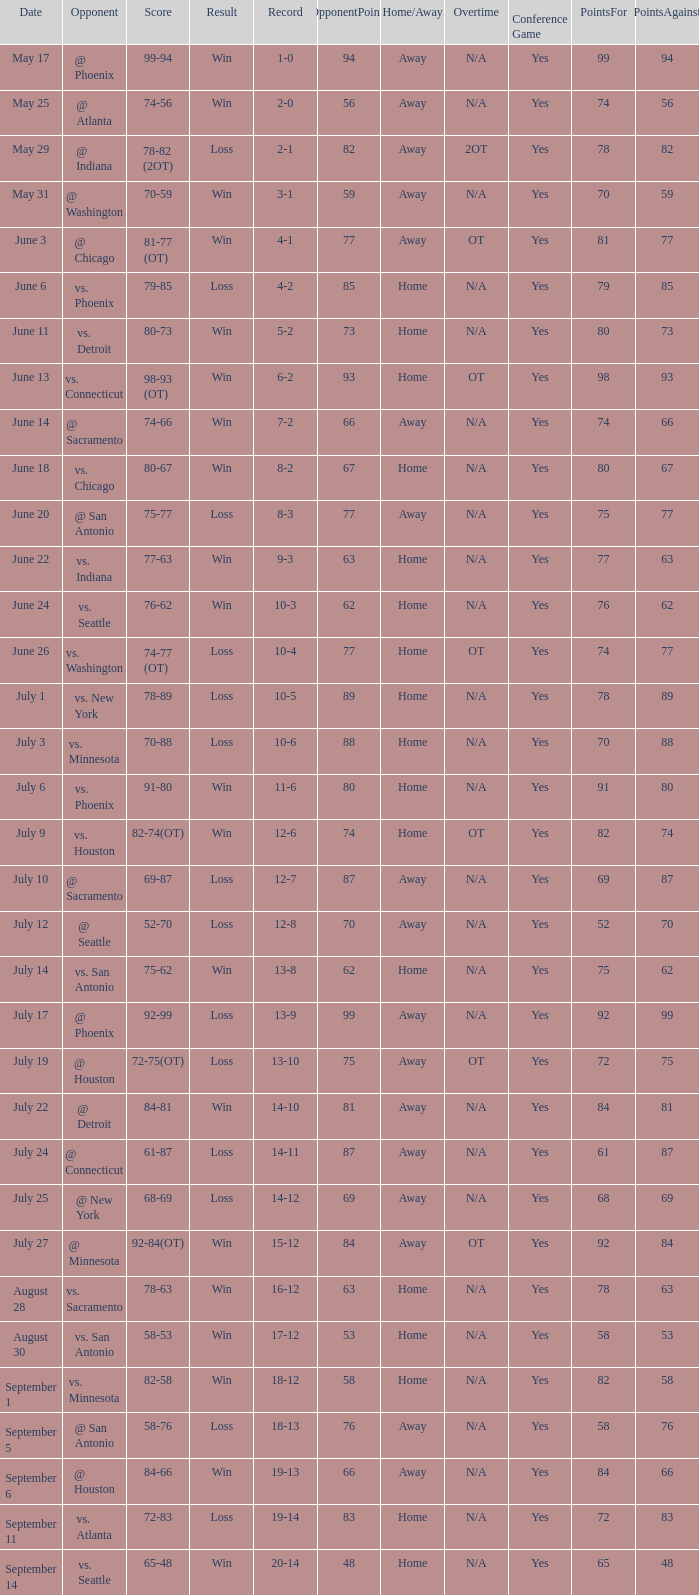What is the Score of the game @ San Antonio on June 20? 75-77. 